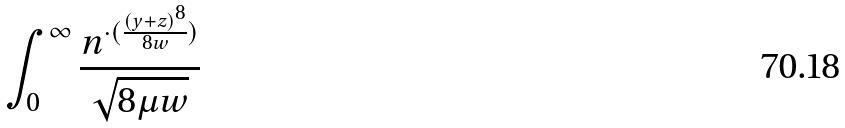<formula> <loc_0><loc_0><loc_500><loc_500>\int _ { 0 } ^ { \infty } \frac { n ^ { \cdot ( \frac { ( y + z ) ^ { 8 } } { 8 w } ) } } { \sqrt { 8 \mu w } }</formula> 